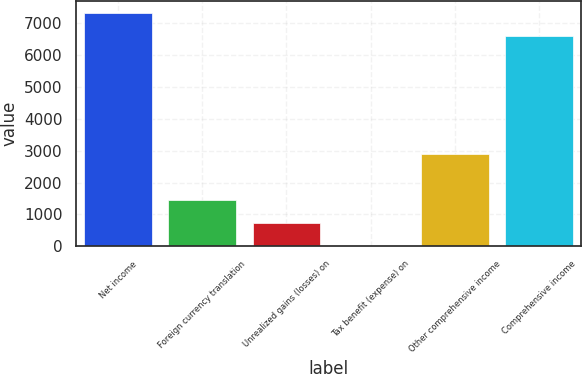Convert chart to OTSL. <chart><loc_0><loc_0><loc_500><loc_500><bar_chart><fcel>Net income<fcel>Foreign currency translation<fcel>Unrealized gains (losses) on<fcel>Tax benefit (expense) on<fcel>Other comprehensive income<fcel>Comprehensive income<nl><fcel>7342.3<fcel>1455.6<fcel>729.3<fcel>3<fcel>2908.2<fcel>6616<nl></chart> 